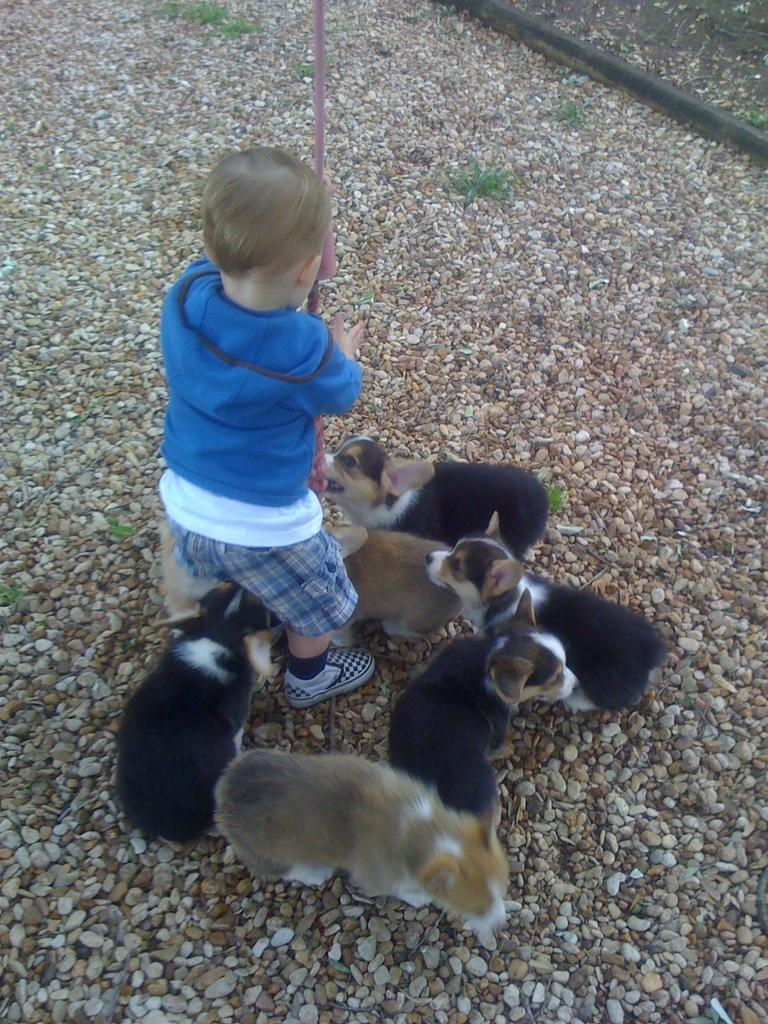Who is the main subject in the image? There is a boy in the image. What is the boy wearing? The boy is wearing a blue t-shirt and shorts. What activity is the boy engaged in? The boy is playing with puppies. What object is the boy holding in his hands? The boy is holding a stick in his hands. What can be seen on the ground in the image? There are stones on the ground in the image. What type of tray is the boy using to carry the puppies in the image? There is no tray present in the image; the boy is playing with puppies without any tray. 